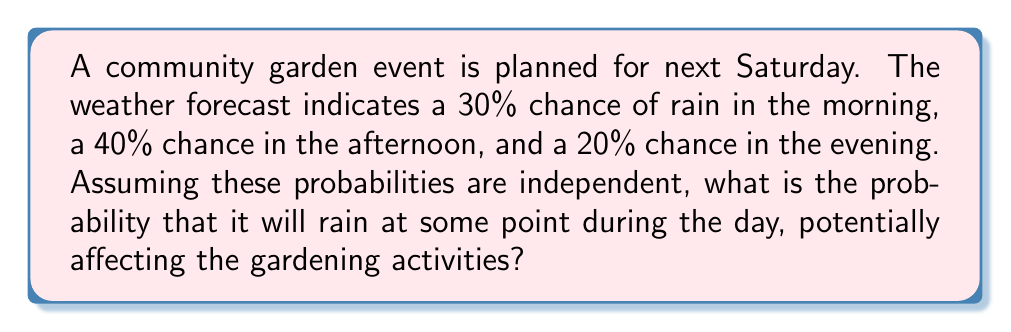Could you help me with this problem? Let's approach this step-by-step:

1) First, we need to find the probability that it doesn't rain at all during the day. We can do this by calculating the probability of no rain in each part of the day and multiplying these probabilities together.

2) Probability of no rain in the morning: $1 - 0.30 = 0.70$
   Probability of no rain in the afternoon: $1 - 0.40 = 0.60$
   Probability of no rain in the evening: $1 - 0.20 = 0.80$

3) Probability of no rain all day:
   $$P(\text{no rain}) = 0.70 \times 0.60 \times 0.80 = 0.336$$

4) The probability that it will rain at some point during the day is the complement of the probability that it doesn't rain at all:

   $$P(\text{rain}) = 1 - P(\text{no rain}) = 1 - 0.336 = 0.664$$

5) Therefore, the probability that it will rain at some point during the day is 0.664 or 66.4%.
Answer: 0.664 or 66.4% 